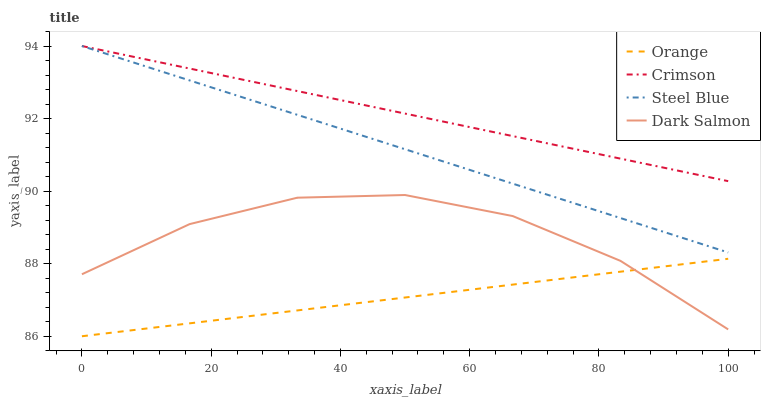Does Orange have the minimum area under the curve?
Answer yes or no. Yes. Does Crimson have the maximum area under the curve?
Answer yes or no. Yes. Does Steel Blue have the minimum area under the curve?
Answer yes or no. No. Does Steel Blue have the maximum area under the curve?
Answer yes or no. No. Is Orange the smoothest?
Answer yes or no. Yes. Is Dark Salmon the roughest?
Answer yes or no. Yes. Is Crimson the smoothest?
Answer yes or no. No. Is Crimson the roughest?
Answer yes or no. No. Does Orange have the lowest value?
Answer yes or no. Yes. Does Steel Blue have the lowest value?
Answer yes or no. No. Does Steel Blue have the highest value?
Answer yes or no. Yes. Does Dark Salmon have the highest value?
Answer yes or no. No. Is Orange less than Steel Blue?
Answer yes or no. Yes. Is Steel Blue greater than Dark Salmon?
Answer yes or no. Yes. Does Orange intersect Dark Salmon?
Answer yes or no. Yes. Is Orange less than Dark Salmon?
Answer yes or no. No. Is Orange greater than Dark Salmon?
Answer yes or no. No. Does Orange intersect Steel Blue?
Answer yes or no. No. 